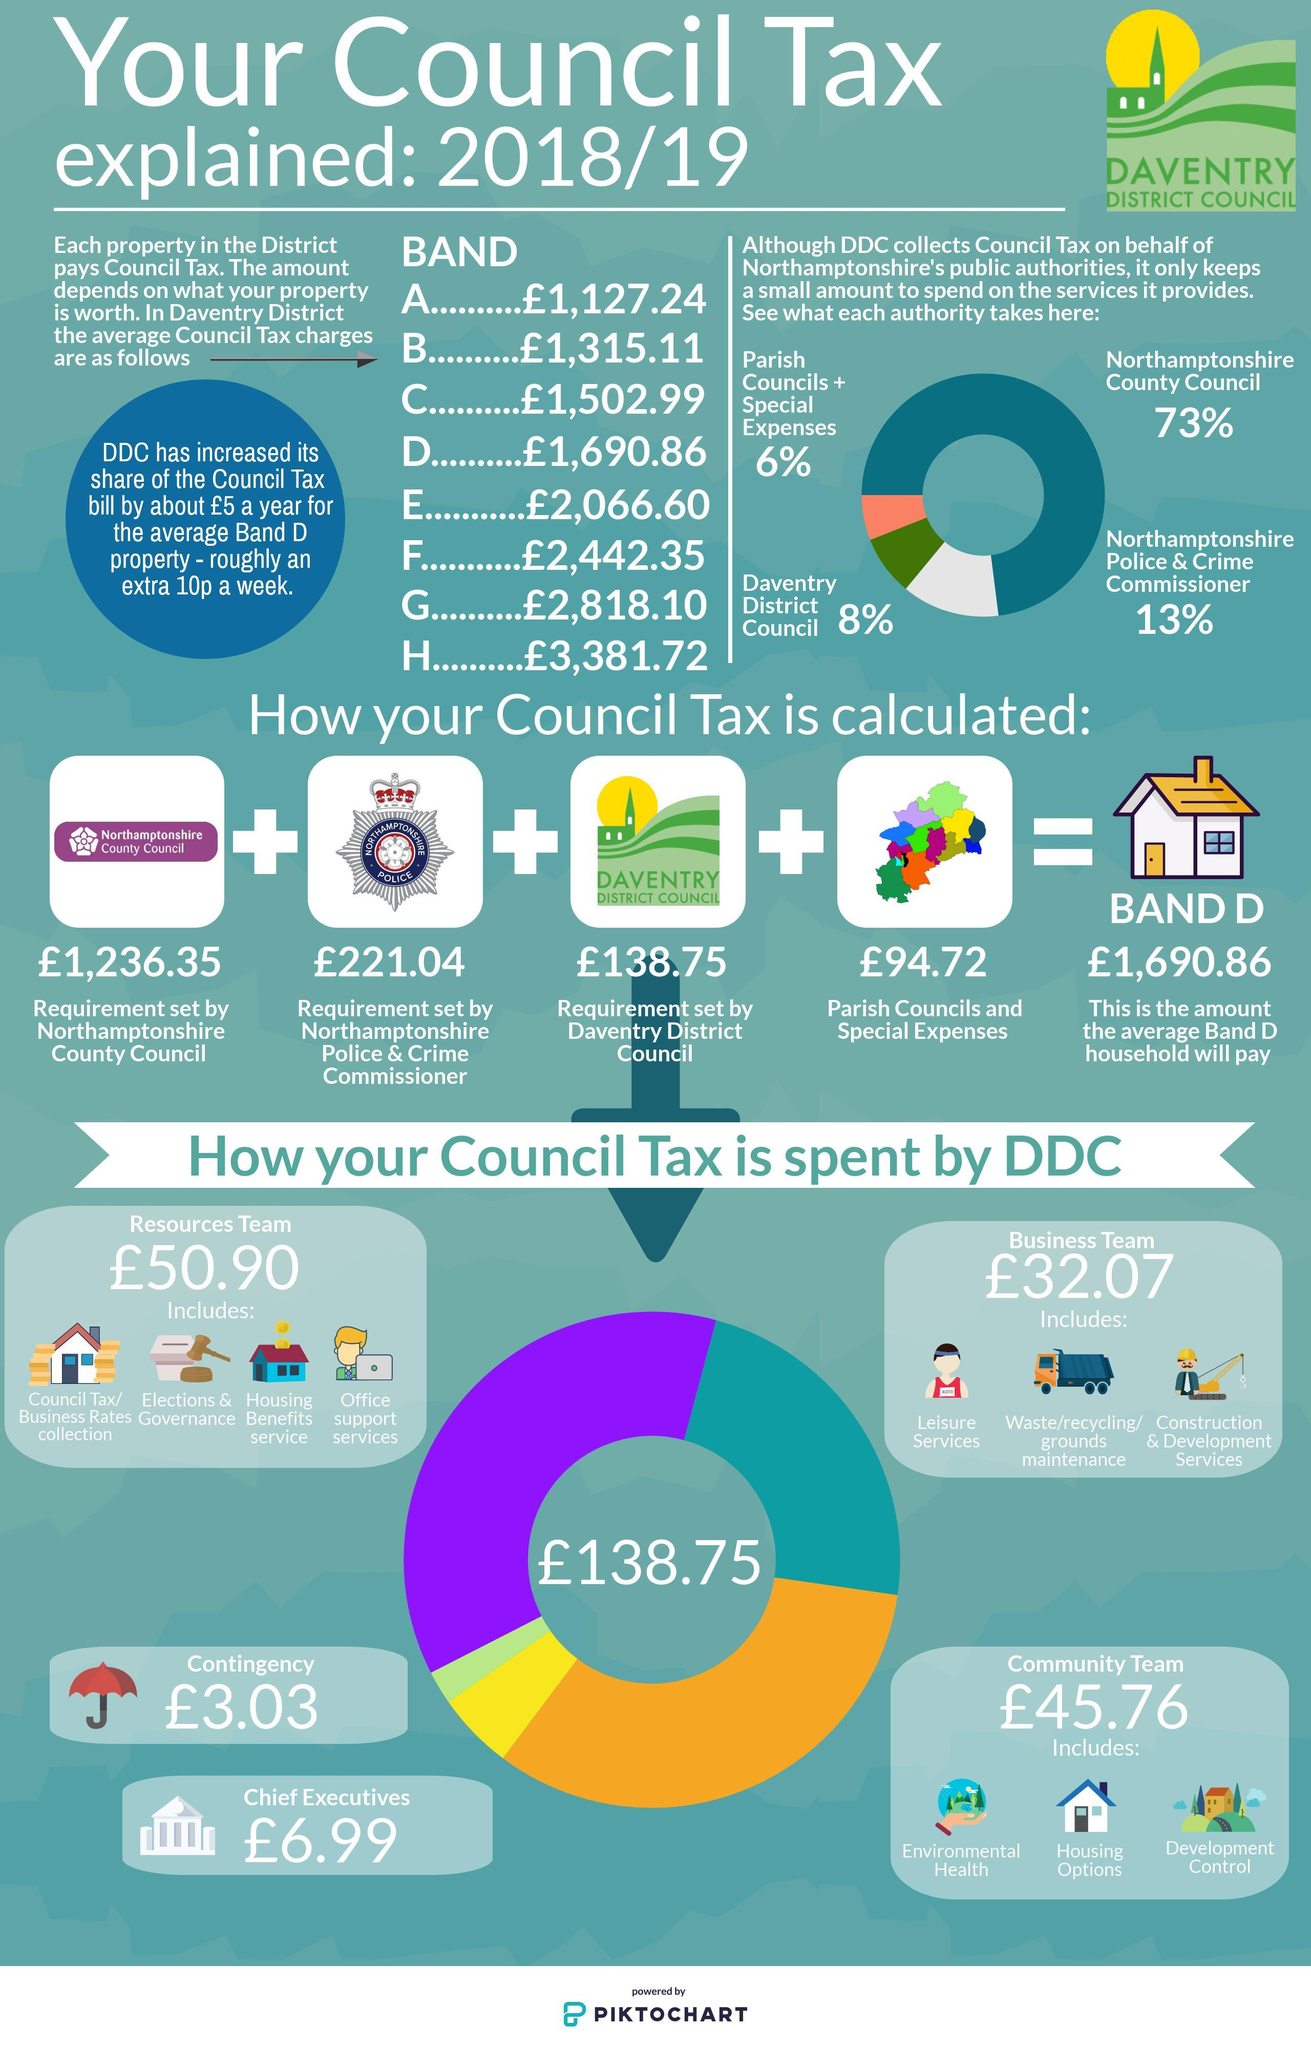Which band has to pay the second highest council tax?
Answer the question with a short phrase. Band G How many components are included while accounting for the council tax of Band D ? 4 What is the share taken by DDC from the Council Tax calculated for Band D? 138.75 pounds Calculate the total council tax to paid by band A, B, and C? 3,945.34 pounds Which authority takes the second highest percentage share from the Council Tax? Northamptonshire Police & Crime Commissioner 